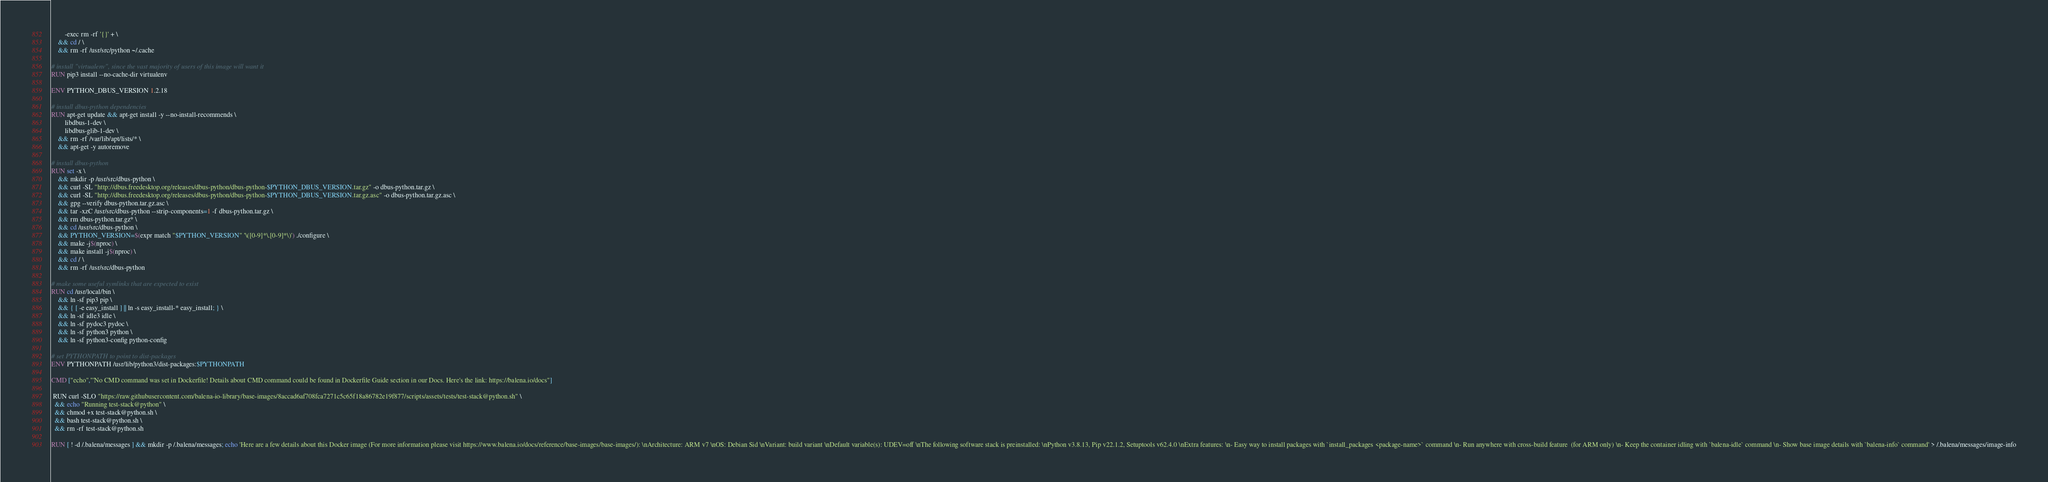Convert code to text. <code><loc_0><loc_0><loc_500><loc_500><_Dockerfile_>        -exec rm -rf '{}' + \
    && cd / \
    && rm -rf /usr/src/python ~/.cache

# install "virtualenv", since the vast majority of users of this image will want it
RUN pip3 install --no-cache-dir virtualenv

ENV PYTHON_DBUS_VERSION 1.2.18

# install dbus-python dependencies 
RUN apt-get update && apt-get install -y --no-install-recommends \
		libdbus-1-dev \
		libdbus-glib-1-dev \
	&& rm -rf /var/lib/apt/lists/* \
	&& apt-get -y autoremove

# install dbus-python
RUN set -x \
	&& mkdir -p /usr/src/dbus-python \
	&& curl -SL "http://dbus.freedesktop.org/releases/dbus-python/dbus-python-$PYTHON_DBUS_VERSION.tar.gz" -o dbus-python.tar.gz \
	&& curl -SL "http://dbus.freedesktop.org/releases/dbus-python/dbus-python-$PYTHON_DBUS_VERSION.tar.gz.asc" -o dbus-python.tar.gz.asc \
	&& gpg --verify dbus-python.tar.gz.asc \
	&& tar -xzC /usr/src/dbus-python --strip-components=1 -f dbus-python.tar.gz \
	&& rm dbus-python.tar.gz* \
	&& cd /usr/src/dbus-python \
	&& PYTHON_VERSION=$(expr match "$PYTHON_VERSION" '\([0-9]*\.[0-9]*\)') ./configure \
	&& make -j$(nproc) \
	&& make install -j$(nproc) \
	&& cd / \
	&& rm -rf /usr/src/dbus-python

# make some useful symlinks that are expected to exist
RUN cd /usr/local/bin \
	&& ln -sf pip3 pip \
	&& { [ -e easy_install ] || ln -s easy_install-* easy_install; } \
	&& ln -sf idle3 idle \
	&& ln -sf pydoc3 pydoc \
	&& ln -sf python3 python \
	&& ln -sf python3-config python-config

# set PYTHONPATH to point to dist-packages
ENV PYTHONPATH /usr/lib/python3/dist-packages:$PYTHONPATH

CMD ["echo","'No CMD command was set in Dockerfile! Details about CMD command could be found in Dockerfile Guide section in our Docs. Here's the link: https://balena.io/docs"]

 RUN curl -SLO "https://raw.githubusercontent.com/balena-io-library/base-images/8accad6af708fca7271c5c65f18a86782e19f877/scripts/assets/tests/test-stack@python.sh" \
  && echo "Running test-stack@python" \
  && chmod +x test-stack@python.sh \
  && bash test-stack@python.sh \
  && rm -rf test-stack@python.sh 

RUN [ ! -d /.balena/messages ] && mkdir -p /.balena/messages; echo 'Here are a few details about this Docker image (For more information please visit https://www.balena.io/docs/reference/base-images/base-images/): \nArchitecture: ARM v7 \nOS: Debian Sid \nVariant: build variant \nDefault variable(s): UDEV=off \nThe following software stack is preinstalled: \nPython v3.8.13, Pip v22.1.2, Setuptools v62.4.0 \nExtra features: \n- Easy way to install packages with `install_packages <package-name>` command \n- Run anywhere with cross-build feature  (for ARM only) \n- Keep the container idling with `balena-idle` command \n- Show base image details with `balena-info` command' > /.balena/messages/image-info</code> 